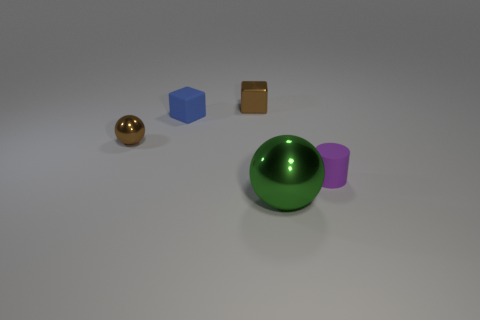Are there any other things that have the same size as the green object?
Provide a short and direct response. No. Are there more cylinders that are in front of the tiny blue cube than metallic blocks in front of the small cylinder?
Your answer should be compact. Yes. The green shiny sphere is what size?
Your answer should be very brief. Large. Do the shiny sphere that is behind the tiny purple object and the shiny cube have the same color?
Provide a succinct answer. Yes. Is there any other thing that is the same shape as the tiny purple matte thing?
Offer a very short reply. No. There is a metallic sphere behind the large metallic ball; are there any small brown objects to the right of it?
Provide a short and direct response. Yes. Are there fewer small brown metallic things behind the small blue cube than tiny things on the left side of the tiny cylinder?
Give a very brief answer. Yes. There is a brown metallic object to the right of the tiny matte object behind the small rubber cylinder on the right side of the brown shiny ball; how big is it?
Make the answer very short. Small. There is a matte object that is to the right of the blue object; does it have the same size as the blue matte object?
Give a very brief answer. Yes. What number of other objects are the same material as the big ball?
Your answer should be compact. 2. 